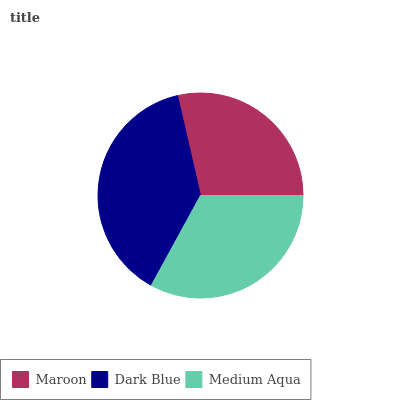Is Maroon the minimum?
Answer yes or no. Yes. Is Dark Blue the maximum?
Answer yes or no. Yes. Is Medium Aqua the minimum?
Answer yes or no. No. Is Medium Aqua the maximum?
Answer yes or no. No. Is Dark Blue greater than Medium Aqua?
Answer yes or no. Yes. Is Medium Aqua less than Dark Blue?
Answer yes or no. Yes. Is Medium Aqua greater than Dark Blue?
Answer yes or no. No. Is Dark Blue less than Medium Aqua?
Answer yes or no. No. Is Medium Aqua the high median?
Answer yes or no. Yes. Is Medium Aqua the low median?
Answer yes or no. Yes. Is Dark Blue the high median?
Answer yes or no. No. Is Dark Blue the low median?
Answer yes or no. No. 